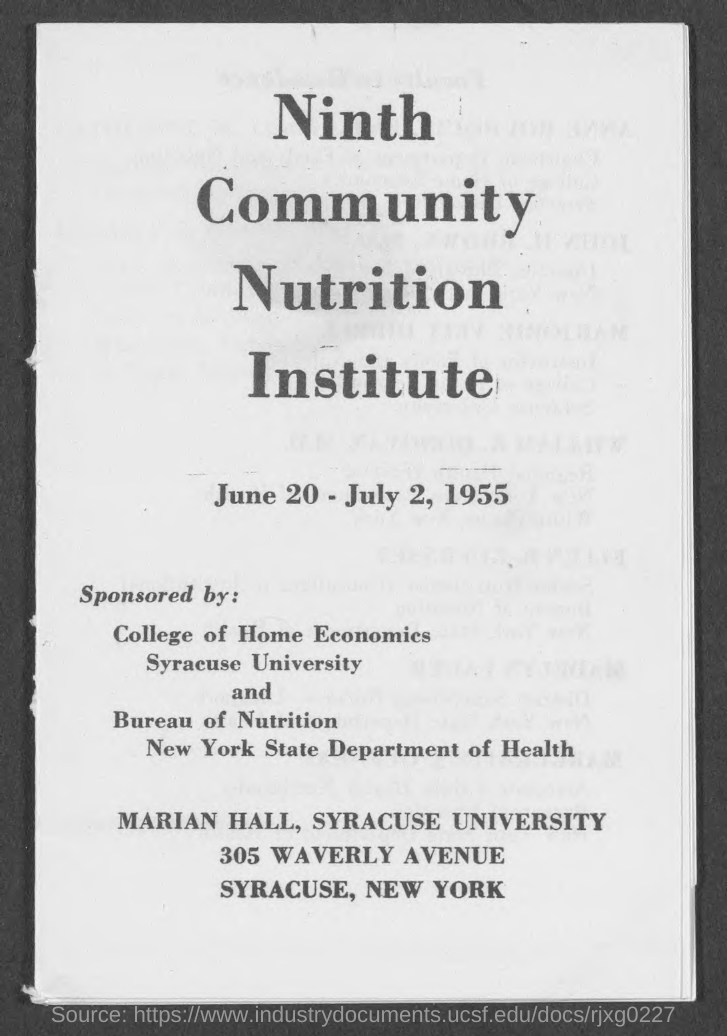Who all  sponsor the program "Ninth Community Nutrition institute " ?
Your answer should be compact. College of Home Economics Syracuse University and Bureau of Nutrition New York State Department of Health. When the program is conducted ?
Your answer should be very brief. June 20 - July 2, 1955. What is the title of the program ?
Offer a very short reply. Ninth Community Nutrition Institute. In which hall, the program is conducted ?
Your answer should be compact. MARIAN HALL. Which university conduct the program ?
Make the answer very short. SYRACUSE UNIVERSITY. In which country,does this program is conducted ?
Provide a short and direct response. NEW YORK. 